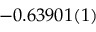Convert formula to latex. <formula><loc_0><loc_0><loc_500><loc_500>- 0 . 6 3 9 0 1 ( 1 )</formula> 